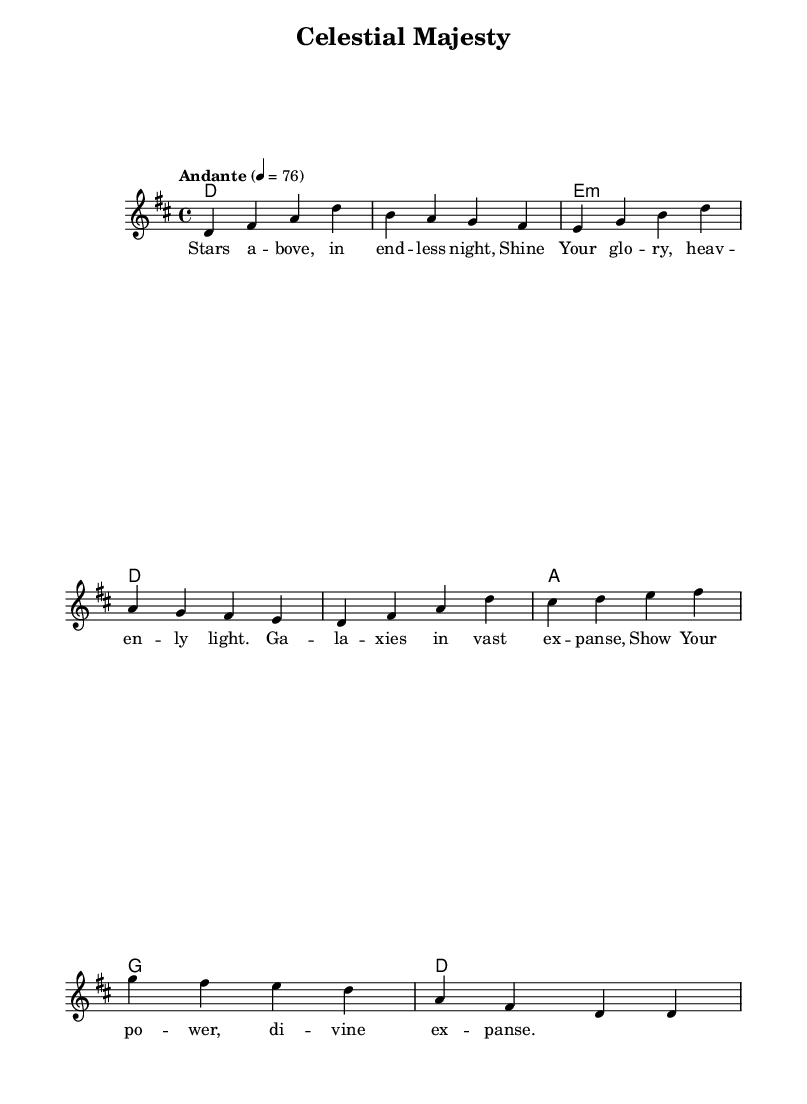What is the key signature of this music? The key signature is indicated by the number of sharps or flats at the beginning of the staff. In this case, it is D major, which has two sharps.
Answer: D major What is the time signature of this piece? The time signature is found at the beginning of the score and specifies how many beats are in each measure. Here, it is 4/4, meaning there are four beats in each measure.
Answer: 4/4 What is the tempo marking of this hymn? The tempo marking is stated in a descriptive term, indicating the speed of the music. In this sheet, it indicates that the piece should be played at "Andante," which means a moderately slow pace.
Answer: Andante How many verses does this hymn have according to the provided lyrics? By examining the lyrics section in the code, we can see it contains one verse, as there is only one stanza of lyrics presented.
Answer: One What is the first lyric of the hymn? The first lyric of the hymn can be identified by looking at the lyrics section of the sheet music. The lyrics start with "Stars above."
Answer: Stars above What is the harmony progression used in the first measure? The harmony progression is indicated in the chord section and describes the chords played in order. In the first measure, the harmony is a D major chord.
Answer: D How many measures are present in the melody? By counting the number of distinct sets of note values in the melody section, we can determine the number of measures. There are eight measures in the melody.
Answer: Eight 